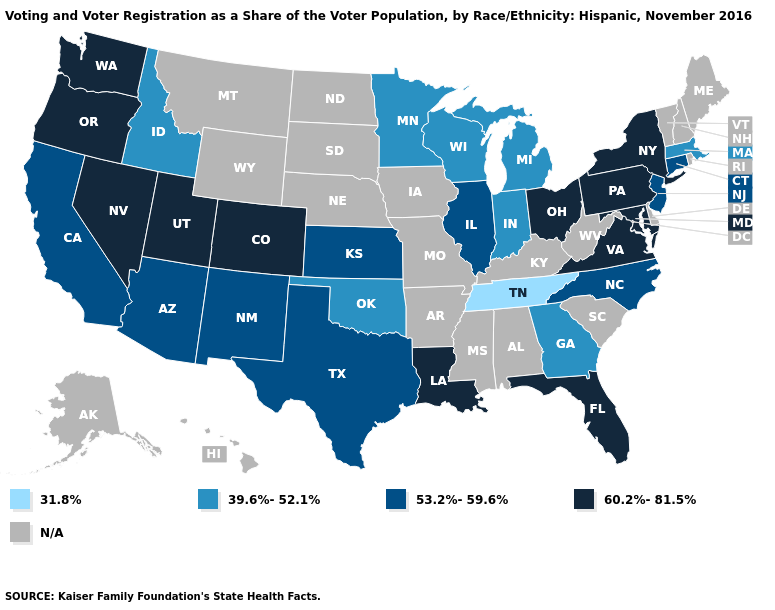Which states have the lowest value in the USA?
Quick response, please. Tennessee. Name the states that have a value in the range 60.2%-81.5%?
Write a very short answer. Colorado, Florida, Louisiana, Maryland, Nevada, New York, Ohio, Oregon, Pennsylvania, Utah, Virginia, Washington. Which states hav the highest value in the MidWest?
Give a very brief answer. Ohio. Which states have the lowest value in the MidWest?
Answer briefly. Indiana, Michigan, Minnesota, Wisconsin. What is the lowest value in the USA?
Quick response, please. 31.8%. What is the value of Connecticut?
Answer briefly. 53.2%-59.6%. What is the value of Utah?
Answer briefly. 60.2%-81.5%. Among the states that border Pennsylvania , does New Jersey have the highest value?
Quick response, please. No. Name the states that have a value in the range 39.6%-52.1%?
Short answer required. Georgia, Idaho, Indiana, Massachusetts, Michigan, Minnesota, Oklahoma, Wisconsin. Does Virginia have the highest value in the USA?
Give a very brief answer. Yes. Name the states that have a value in the range 31.8%?
Short answer required. Tennessee. Name the states that have a value in the range 60.2%-81.5%?
Concise answer only. Colorado, Florida, Louisiana, Maryland, Nevada, New York, Ohio, Oregon, Pennsylvania, Utah, Virginia, Washington. Which states have the lowest value in the USA?
Answer briefly. Tennessee. Name the states that have a value in the range 60.2%-81.5%?
Write a very short answer. Colorado, Florida, Louisiana, Maryland, Nevada, New York, Ohio, Oregon, Pennsylvania, Utah, Virginia, Washington. 